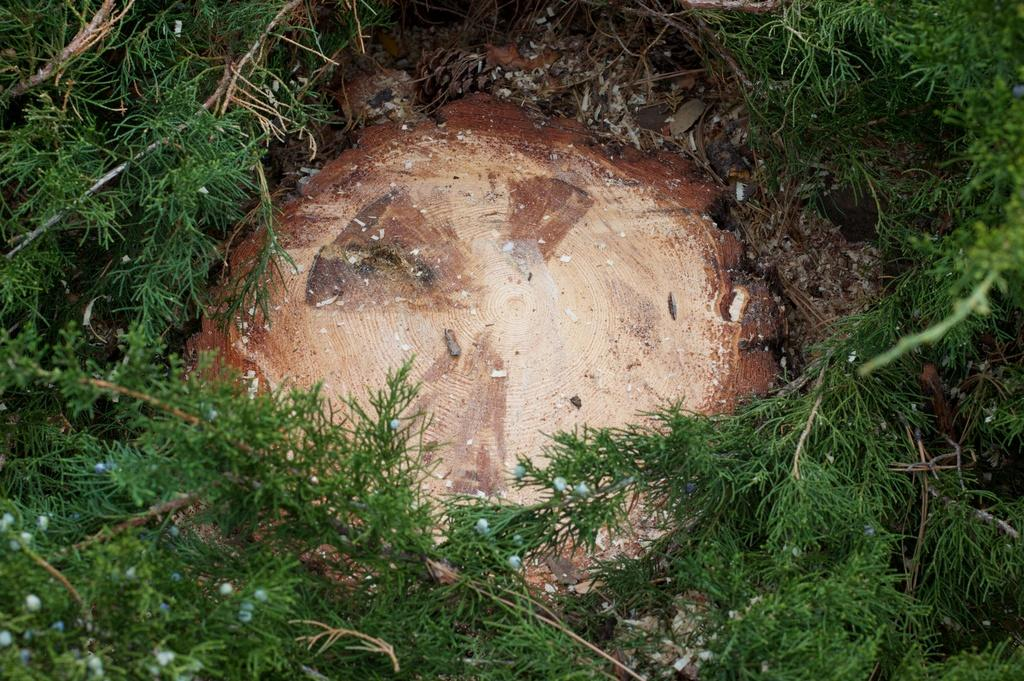Where was the picture taken? The picture was clicked outside. What can be seen on the ground in the image? There are stones on the ground in the image. What type of vegetation is present in the image? There are plants in the image, and plant stems are also visible. What type of cheese is being served by the servant in the image? There is no cheese or servant present in the image. How is the light source affecting the plants in the image? The image does not provide information about the light source or its effect on the plants. 